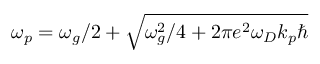<formula> <loc_0><loc_0><loc_500><loc_500>\omega _ { p } = \omega _ { g } / 2 + \sqrt { \omega _ { g } ^ { 2 } / 4 + 2 \pi e ^ { 2 } \omega _ { D } k _ { p } }</formula> 